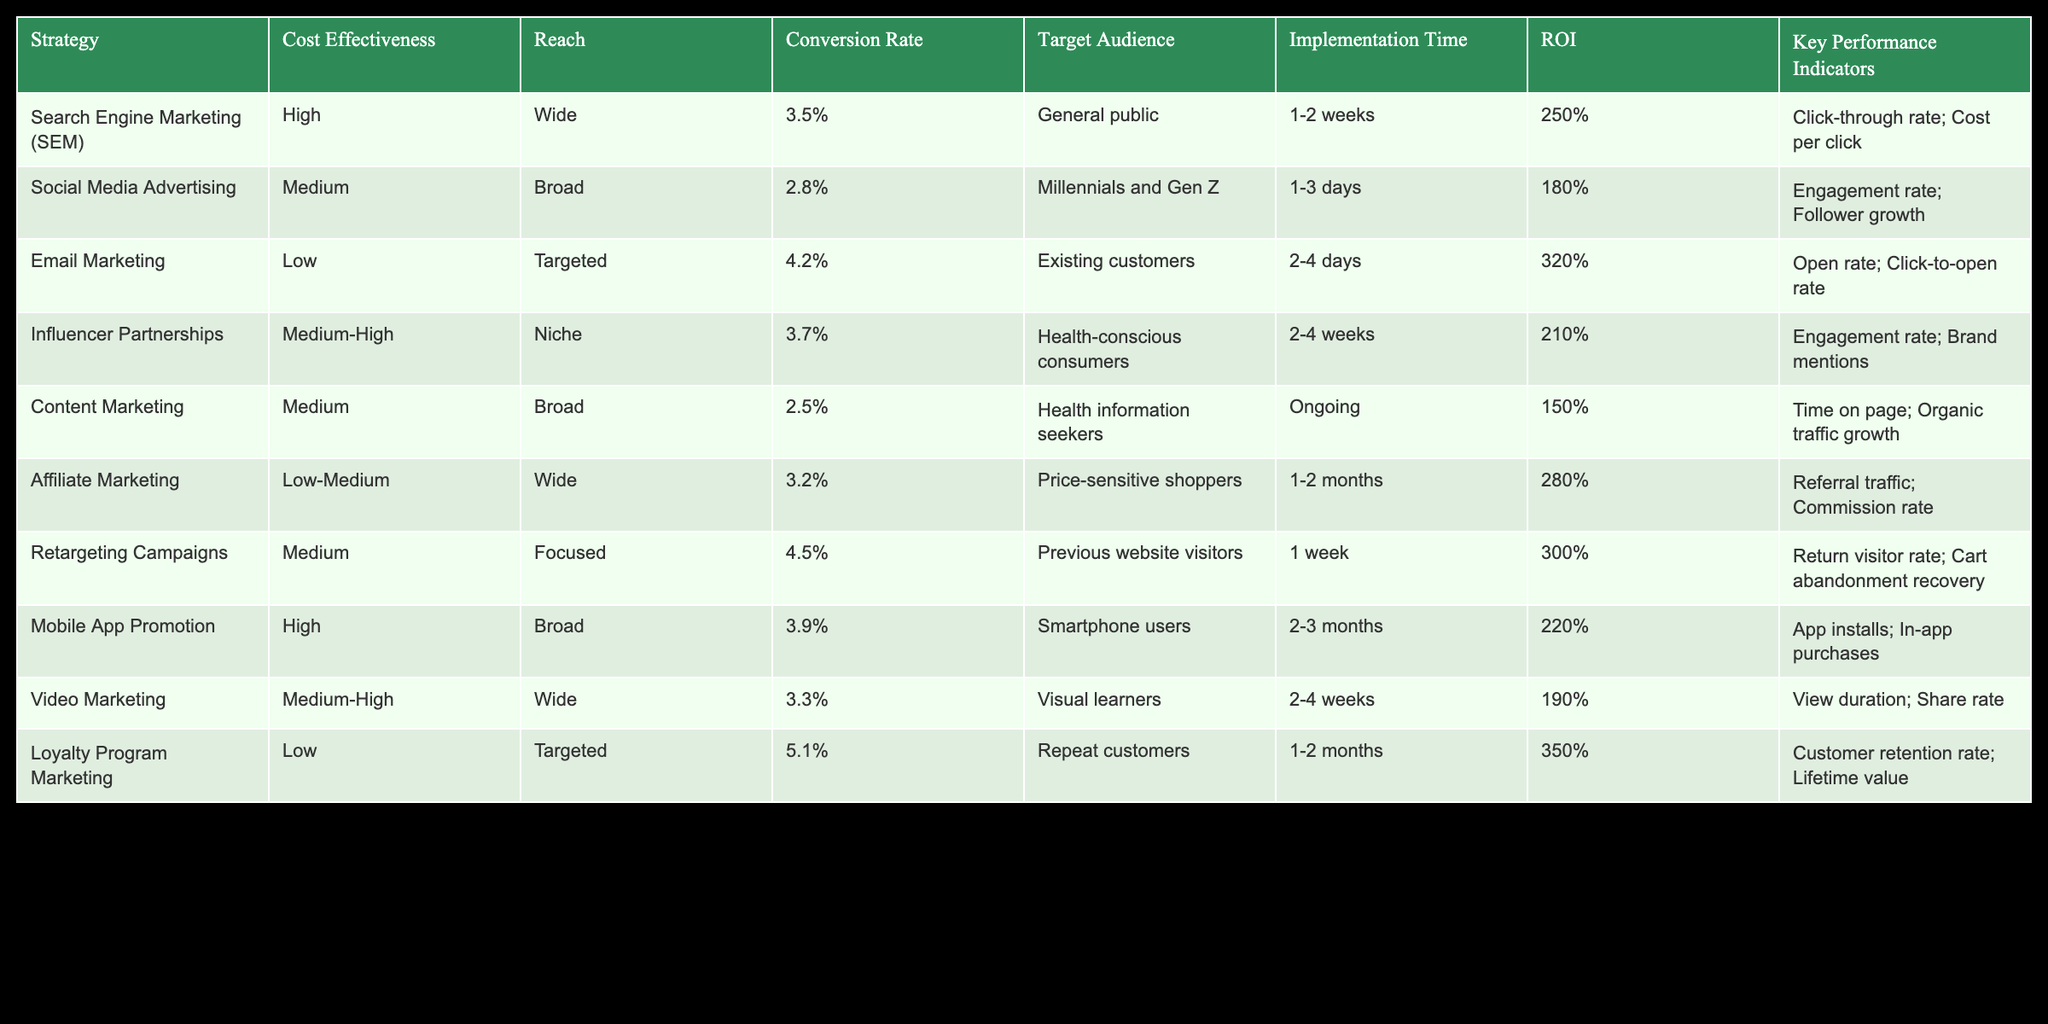What is the conversion rate for Email Marketing? From the table, I locate the row corresponding to Email Marketing and read across to the Conversion Rate column, where it shows 4.2%.
Answer: 4.2% Which strategy has the highest ROI? I review the ROI column across all strategies and find that the Loyalty Program Marketing has the highest value at 350%.
Answer: 350% Is the reach of Video Marketing wider than that of Content Marketing? I compare the Reach columns for both strategies: Video Marketing shows "Wide," while Content Marketing shows "Broad." Since "Wide" generally indicates a larger audience than "Broad," it confirms that Video Marketing has a wider reach.
Answer: Yes What is the average conversion rate of the strategies targeting the general public? The two strategies targeting the general public are Search Engine Marketing and Mobile App Promotion. Their conversion rates are 3.5% and 3.9% respectively. The average is calculated as (3.5 + 3.9) / 2 = 3.7%.
Answer: 3.7% Does Social Media Advertising have a higher cost effectiveness than Influencer Partnerships? In the Cost Effectiveness column, Social Media Advertising is marked as "Medium" and Influencer Partnerships as "Medium-High." Since "Medium-High" indicates greater effectiveness, Social Media Advertising does not have a higher cost effectiveness.
Answer: No 